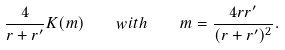Convert formula to latex. <formula><loc_0><loc_0><loc_500><loc_500>\frac { 4 } { r + r ^ { \prime } } K ( m ) \quad w i t h \quad m = \frac { 4 r r ^ { \prime } } { ( r + r ^ { \prime } ) ^ { 2 } } .</formula> 